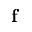<formula> <loc_0><loc_0><loc_500><loc_500>f</formula> 